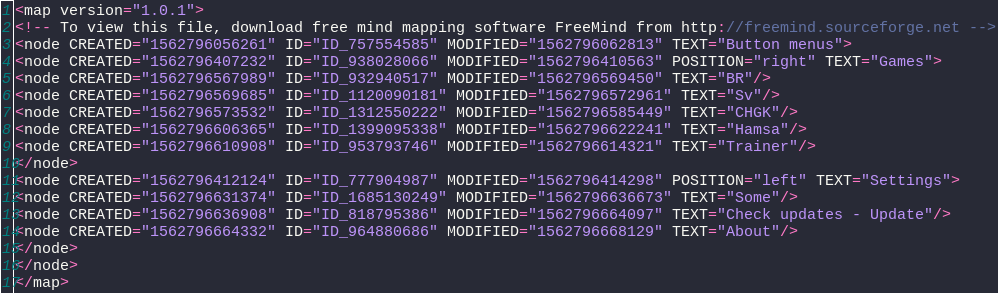<code> <loc_0><loc_0><loc_500><loc_500><_ObjectiveC_><map version="1.0.1">
<!-- To view this file, download free mind mapping software FreeMind from http://freemind.sourceforge.net -->
<node CREATED="1562796056261" ID="ID_757554585" MODIFIED="1562796062813" TEXT="Button menus">
<node CREATED="1562796407232" ID="ID_938028066" MODIFIED="1562796410563" POSITION="right" TEXT="Games">
<node CREATED="1562796567989" ID="ID_932940517" MODIFIED="1562796569450" TEXT="BR"/>
<node CREATED="1562796569685" ID="ID_1120090181" MODIFIED="1562796572961" TEXT="Sv"/>
<node CREATED="1562796573532" ID="ID_1312550222" MODIFIED="1562796585449" TEXT="CHGK"/>
<node CREATED="1562796606365" ID="ID_1399095338" MODIFIED="1562796622241" TEXT="Hamsa"/>
<node CREATED="1562796610908" ID="ID_953793746" MODIFIED="1562796614321" TEXT="Trainer"/>
</node>
<node CREATED="1562796412124" ID="ID_777904987" MODIFIED="1562796414298" POSITION="left" TEXT="Settings">
<node CREATED="1562796631374" ID="ID_1685130249" MODIFIED="1562796636673" TEXT="Some"/>
<node CREATED="1562796636908" ID="ID_818795386" MODIFIED="1562796664097" TEXT="Check updates - Update"/>
<node CREATED="1562796664332" ID="ID_964880686" MODIFIED="1562796668129" TEXT="About"/>
</node>
</node>
</map>
</code> 